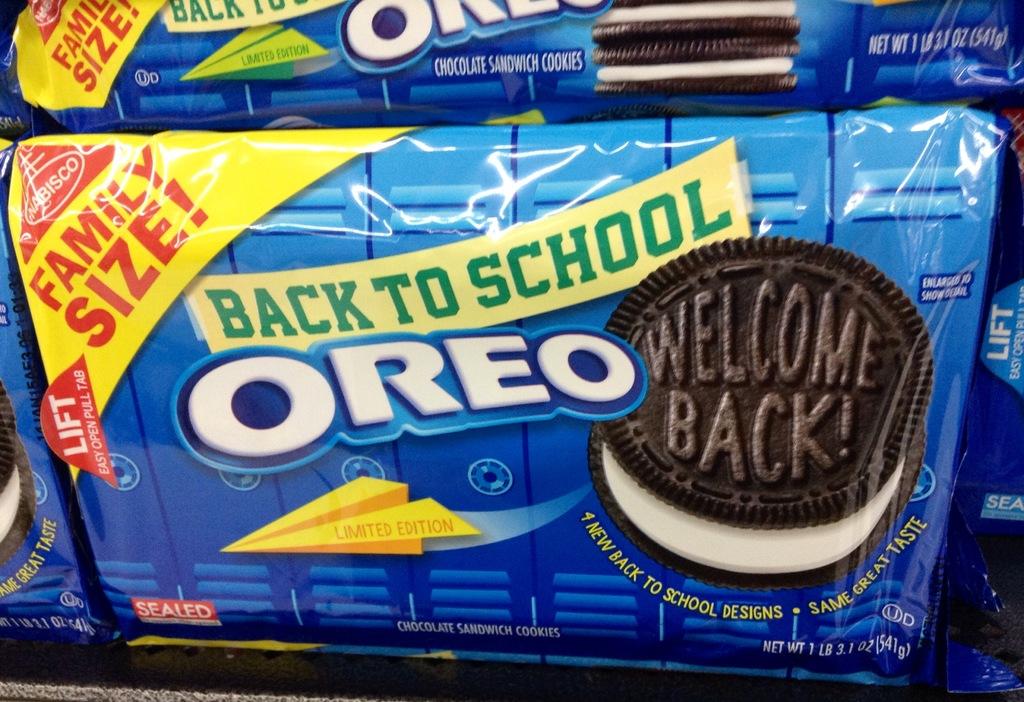What size is the oreo?
Ensure brevity in your answer.  Family. What is written on the cookie top?
Give a very brief answer. Welcome back!. 